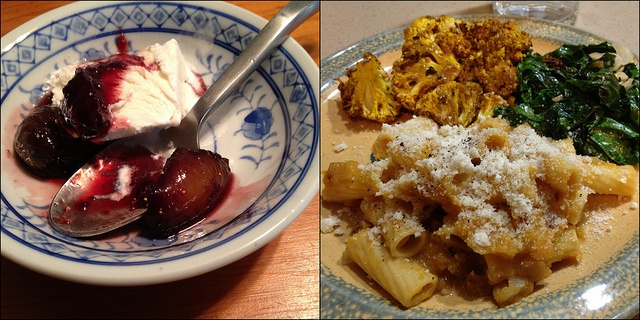Describe the objects in this image and their specific colors. I can see bowl in black, darkgray, gray, and maroon tones, spoon in black, maroon, and gray tones, and cup in black, darkgray, and gray tones in this image. 